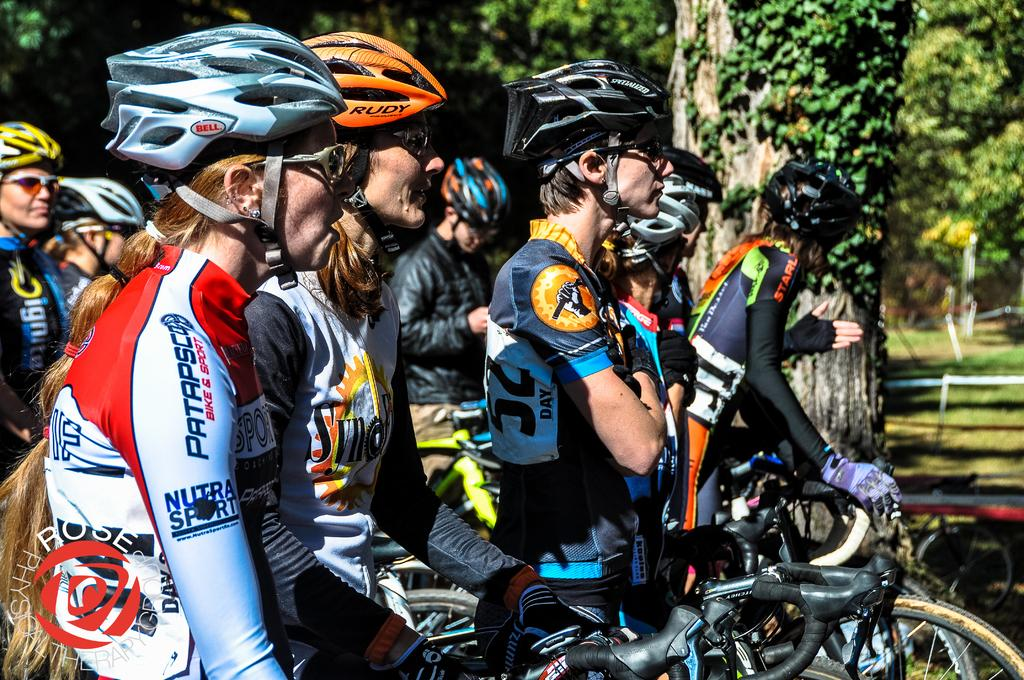Who is present in the image? There are people in the image. What are the people wearing on their heads? The people are wearing helmets. What are the people riding in the image? The people are on bicycles. What type of natural elements can be seen in the image? There are trees and plants in the image. What type of pet is sitting on the manager's lap in the image? There is no manager or pet present in the image. Can you describe the rose in the image? There is no rose present in the image. 